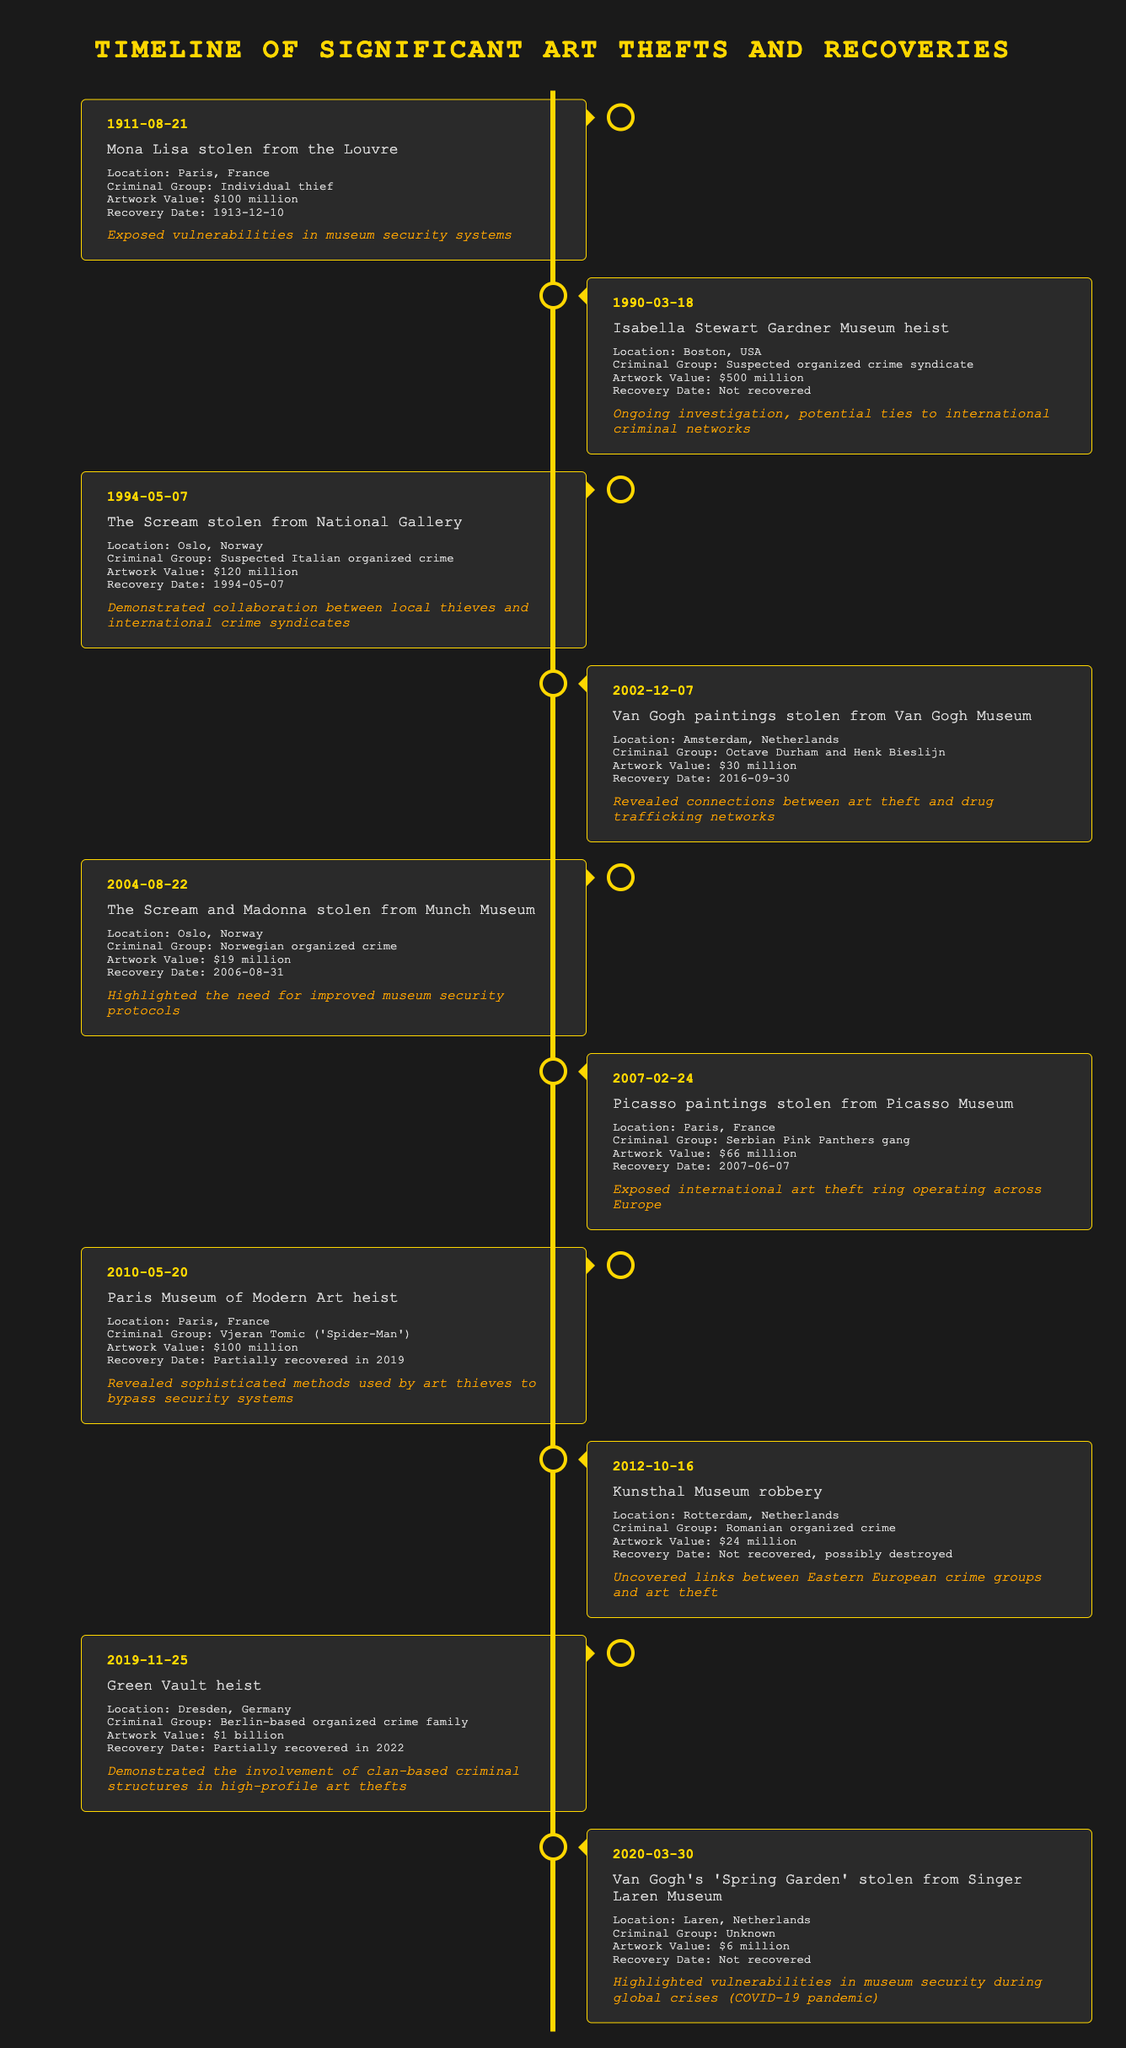What event occurred on March 18, 1990? The table lists the event that occurred on this date as the Isabella Stewart Gardner Museum heist in Boston, USA.
Answer: Isabella Stewart Gardner Museum heist How many art thefts mentioned in the table were associated with organized crime? By reviewing the table, the events linked to organized crime are: Isabella Stewart Gardner Museum heist, The Scream stolen from National Gallery, Van Gogh paintings stolen from Van Gogh Museum, The Scream and Madonna stolen from Munch Museum, Picasso paintings stolen from Picasso Museum, Kunsthal Museum robbery, Green Vault heist, and Van Gogh's 'Spring Garden' theft. This totals to 8 incidents.
Answer: 8 What is the total value of the artworks stolen in the 2002 Van Gogh Museum theft and the 2004 Munch Museum theft? The artwork value for the Van Gogh Museum theft is $30 million and for the Munch Museum theft is $19 million. Summing these gives $30 million + $19 million = $49 million.
Answer: $49 million Is the Mona Lisa theft linked to organized crime? The Mona Lisa theft was committed by an individual thief, as stated in the table, which indicates that it is not linked to organized crime.
Answer: No What was the significance to intelligence of the Green Vault heist? The significance noted in the table explains that the Green Vault heist demonstrated the involvement of clan-based criminal structures in high-profile art thefts, indicating a connection with organized crime.
Answer: Clan-based criminal structures involvement What was the earliest event listed in the table and what was its significance? The earliest event is the Mona Lisa stolen on August 21, 1911. Its significance highlights the vulnerabilities in museum security systems, pointing to areas of potential improvement.
Answer: Mona Lisa theft, highlighted vulnerabilities in museum security systems In which locations were art thefts listed in 2004? The table indicates that the art thefts listed in 2004 occurred in Oslo, Norway, specifically the theft of The Scream and Madonna.
Answer: Oslo, Norway What is the most valuable artwork mentioned in the table, and what is its value? The most valuable artwork listed is from the Green Vault heist, valued at $1 billion. The table specifies this value directly.
Answer: $1 billion 